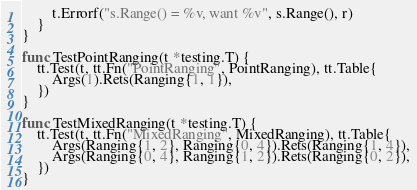<code> <loc_0><loc_0><loc_500><loc_500><_Go_>		t.Errorf("s.Range() = %v, want %v", s.Range(), r)
	}
}

func TestPointRanging(t *testing.T) {
	tt.Test(t, tt.Fn("PointRanging", PointRanging), tt.Table{
		Args(1).Rets(Ranging{1, 1}),
	})
}

func TestMixedRanging(t *testing.T) {
	tt.Test(t, tt.Fn("MixedRanging", MixedRanging), tt.Table{
		Args(Ranging{1, 2}, Ranging{0, 4}).Rets(Ranging{1, 4}),
		Args(Ranging{0, 4}, Ranging{1, 2}).Rets(Ranging{0, 2}),
	})
}
</code> 